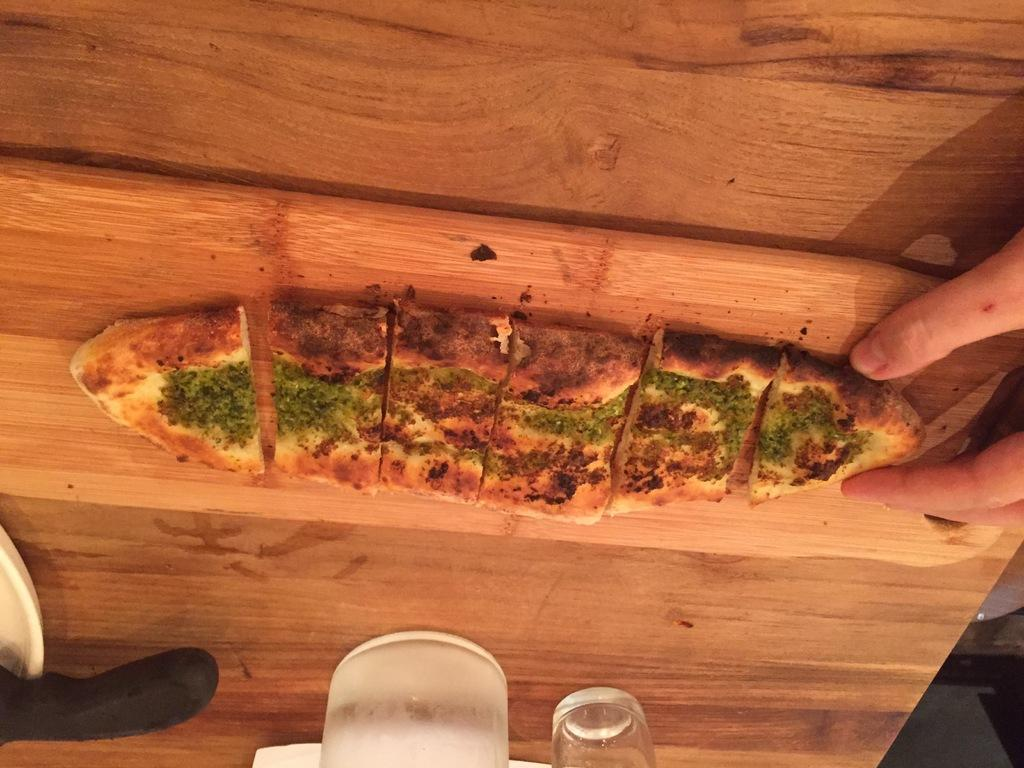What type of food is visible in the image? There is a pizza in the image. On what surface is the pizza placed? The pizza is on a chopping board. What material is the chopping board made of? The chopping board is made of wood. What objects can be seen at the bottom of the image? There are glasses and a knife at the bottom of the image. What type of nail can be seen in the image? There is no nail present in the image. What kind of insect is crawling on the pizza in the image? There is no insect present in the image; it is a pizza on a chopping board. 